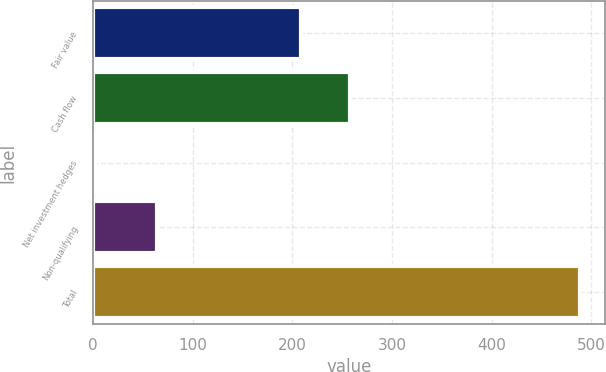Convert chart. <chart><loc_0><loc_0><loc_500><loc_500><bar_chart><fcel>Fair value<fcel>Cash flow<fcel>Net investment hedges<fcel>Non-qualifying<fcel>Total<nl><fcel>209<fcel>257.7<fcel>2<fcel>64<fcel>489<nl></chart> 